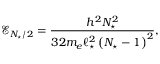<formula> <loc_0><loc_0><loc_500><loc_500>\mathcal { E } _ { N _ { ^ { * } } / 2 } = \frac { h ^ { 2 } N _ { ^ { * } } ^ { 2 } } { 3 2 m _ { e } \ell _ { ^ { * } } ^ { 2 } \left ( N _ { ^ { * } } - 1 \right ) ^ { 2 } } ,</formula> 